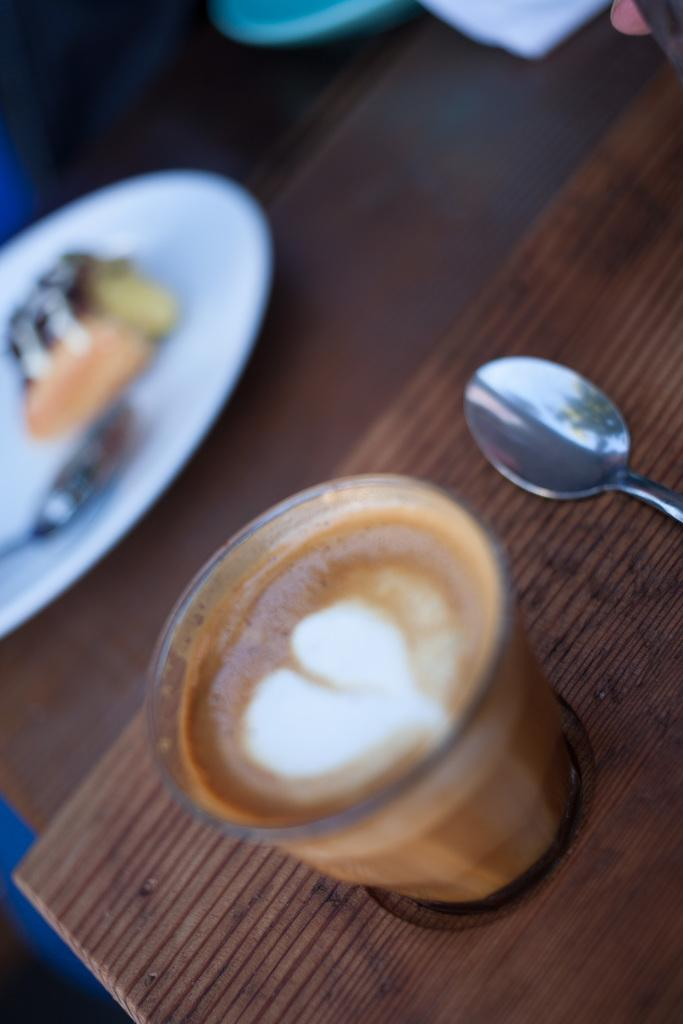What type of glass is visible in the image? There is a coffee glass in the image. What utensil is present in the image? There is a spoon in the image. What is on the plate in the image? There is a plate with food in the image. How many legs does the coffee glass have in the image? The coffee glass does not have legs; it is a glass container for holding liquid. 